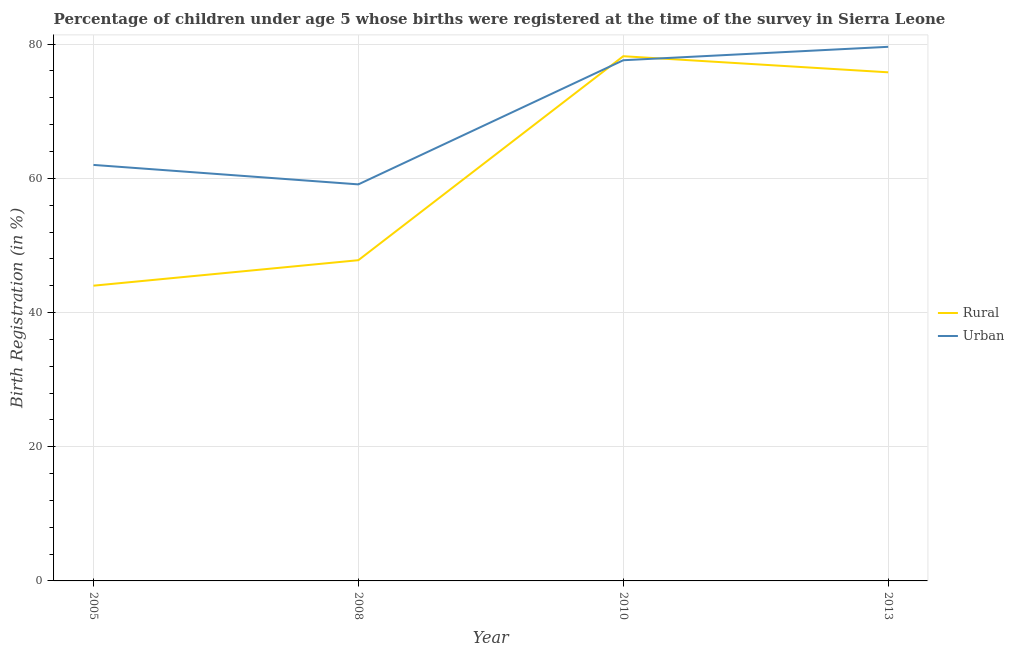How many different coloured lines are there?
Provide a succinct answer. 2. Does the line corresponding to urban birth registration intersect with the line corresponding to rural birth registration?
Your answer should be very brief. Yes. Across all years, what is the maximum urban birth registration?
Your response must be concise. 79.6. In which year was the urban birth registration maximum?
Keep it short and to the point. 2013. What is the total rural birth registration in the graph?
Offer a very short reply. 245.8. What is the difference between the urban birth registration in 2008 and that in 2010?
Make the answer very short. -18.5. What is the difference between the rural birth registration in 2010 and the urban birth registration in 2008?
Keep it short and to the point. 19.1. What is the average urban birth registration per year?
Your answer should be very brief. 69.57. In the year 2005, what is the difference between the urban birth registration and rural birth registration?
Offer a very short reply. 18. In how many years, is the rural birth registration greater than 44 %?
Ensure brevity in your answer.  3. What is the ratio of the urban birth registration in 2005 to that in 2013?
Offer a very short reply. 0.78. What is the difference between the highest and the second highest rural birth registration?
Your answer should be very brief. 2.4. What is the difference between the highest and the lowest rural birth registration?
Your response must be concise. 34.2. In how many years, is the urban birth registration greater than the average urban birth registration taken over all years?
Offer a very short reply. 2. Is the urban birth registration strictly greater than the rural birth registration over the years?
Keep it short and to the point. No. How many lines are there?
Offer a terse response. 2. What is the difference between two consecutive major ticks on the Y-axis?
Your response must be concise. 20. Are the values on the major ticks of Y-axis written in scientific E-notation?
Your answer should be very brief. No. Does the graph contain any zero values?
Your answer should be compact. No. Does the graph contain grids?
Give a very brief answer. Yes. What is the title of the graph?
Offer a terse response. Percentage of children under age 5 whose births were registered at the time of the survey in Sierra Leone. Does "Arms imports" appear as one of the legend labels in the graph?
Offer a very short reply. No. What is the label or title of the Y-axis?
Your response must be concise. Birth Registration (in %). What is the Birth Registration (in %) in Rural in 2008?
Your answer should be compact. 47.8. What is the Birth Registration (in %) of Urban in 2008?
Keep it short and to the point. 59.1. What is the Birth Registration (in %) in Rural in 2010?
Make the answer very short. 78.2. What is the Birth Registration (in %) in Urban in 2010?
Provide a succinct answer. 77.6. What is the Birth Registration (in %) of Rural in 2013?
Offer a terse response. 75.8. What is the Birth Registration (in %) in Urban in 2013?
Make the answer very short. 79.6. Across all years, what is the maximum Birth Registration (in %) of Rural?
Keep it short and to the point. 78.2. Across all years, what is the maximum Birth Registration (in %) in Urban?
Offer a very short reply. 79.6. Across all years, what is the minimum Birth Registration (in %) in Urban?
Provide a short and direct response. 59.1. What is the total Birth Registration (in %) of Rural in the graph?
Make the answer very short. 245.8. What is the total Birth Registration (in %) in Urban in the graph?
Your answer should be compact. 278.3. What is the difference between the Birth Registration (in %) of Rural in 2005 and that in 2010?
Provide a short and direct response. -34.2. What is the difference between the Birth Registration (in %) in Urban in 2005 and that in 2010?
Keep it short and to the point. -15.6. What is the difference between the Birth Registration (in %) in Rural in 2005 and that in 2013?
Give a very brief answer. -31.8. What is the difference between the Birth Registration (in %) in Urban in 2005 and that in 2013?
Give a very brief answer. -17.6. What is the difference between the Birth Registration (in %) in Rural in 2008 and that in 2010?
Keep it short and to the point. -30.4. What is the difference between the Birth Registration (in %) of Urban in 2008 and that in 2010?
Your answer should be compact. -18.5. What is the difference between the Birth Registration (in %) of Rural in 2008 and that in 2013?
Provide a short and direct response. -28. What is the difference between the Birth Registration (in %) of Urban in 2008 and that in 2013?
Provide a short and direct response. -20.5. What is the difference between the Birth Registration (in %) in Urban in 2010 and that in 2013?
Provide a short and direct response. -2. What is the difference between the Birth Registration (in %) in Rural in 2005 and the Birth Registration (in %) in Urban in 2008?
Your answer should be very brief. -15.1. What is the difference between the Birth Registration (in %) in Rural in 2005 and the Birth Registration (in %) in Urban in 2010?
Your answer should be compact. -33.6. What is the difference between the Birth Registration (in %) in Rural in 2005 and the Birth Registration (in %) in Urban in 2013?
Provide a short and direct response. -35.6. What is the difference between the Birth Registration (in %) in Rural in 2008 and the Birth Registration (in %) in Urban in 2010?
Ensure brevity in your answer.  -29.8. What is the difference between the Birth Registration (in %) in Rural in 2008 and the Birth Registration (in %) in Urban in 2013?
Keep it short and to the point. -31.8. What is the average Birth Registration (in %) of Rural per year?
Provide a succinct answer. 61.45. What is the average Birth Registration (in %) in Urban per year?
Keep it short and to the point. 69.58. In the year 2008, what is the difference between the Birth Registration (in %) in Rural and Birth Registration (in %) in Urban?
Give a very brief answer. -11.3. In the year 2013, what is the difference between the Birth Registration (in %) in Rural and Birth Registration (in %) in Urban?
Offer a very short reply. -3.8. What is the ratio of the Birth Registration (in %) in Rural in 2005 to that in 2008?
Offer a very short reply. 0.92. What is the ratio of the Birth Registration (in %) of Urban in 2005 to that in 2008?
Provide a short and direct response. 1.05. What is the ratio of the Birth Registration (in %) of Rural in 2005 to that in 2010?
Offer a terse response. 0.56. What is the ratio of the Birth Registration (in %) of Urban in 2005 to that in 2010?
Your answer should be compact. 0.8. What is the ratio of the Birth Registration (in %) of Rural in 2005 to that in 2013?
Give a very brief answer. 0.58. What is the ratio of the Birth Registration (in %) in Urban in 2005 to that in 2013?
Keep it short and to the point. 0.78. What is the ratio of the Birth Registration (in %) of Rural in 2008 to that in 2010?
Your answer should be very brief. 0.61. What is the ratio of the Birth Registration (in %) in Urban in 2008 to that in 2010?
Your response must be concise. 0.76. What is the ratio of the Birth Registration (in %) in Rural in 2008 to that in 2013?
Ensure brevity in your answer.  0.63. What is the ratio of the Birth Registration (in %) in Urban in 2008 to that in 2013?
Offer a terse response. 0.74. What is the ratio of the Birth Registration (in %) of Rural in 2010 to that in 2013?
Your response must be concise. 1.03. What is the ratio of the Birth Registration (in %) in Urban in 2010 to that in 2013?
Keep it short and to the point. 0.97. What is the difference between the highest and the second highest Birth Registration (in %) in Rural?
Provide a succinct answer. 2.4. What is the difference between the highest and the second highest Birth Registration (in %) of Urban?
Offer a terse response. 2. What is the difference between the highest and the lowest Birth Registration (in %) in Rural?
Keep it short and to the point. 34.2. 